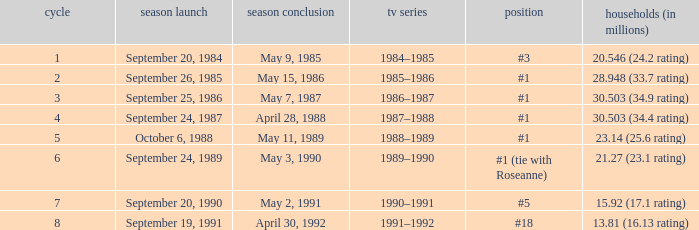Which TV season has a Season smaller than 8, and a Household (in millions) of 15.92 (17.1 rating)? 1990–1991. 